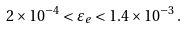<formula> <loc_0><loc_0><loc_500><loc_500>2 \times 1 0 ^ { - 4 } < \varepsilon _ { e } < 1 . 4 \times 1 0 ^ { - 3 } \, .</formula> 